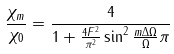Convert formula to latex. <formula><loc_0><loc_0><loc_500><loc_500>\frac { \chi _ { m } } { \chi _ { 0 } } = \frac { 4 } { 1 + \frac { 4 F ^ { 2 } } { \pi ^ { 2 } } \sin ^ { 2 } { \frac { m \Delta \Omega } { \Omega } \pi } }</formula> 